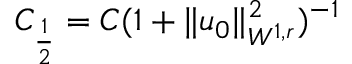<formula> <loc_0><loc_0><loc_500><loc_500>C _ { \frac { 1 } { 2 } } = C ( 1 + \| u _ { 0 } \| _ { W ^ { 1 , r } } ^ { 2 } ) ^ { - 1 }</formula> 